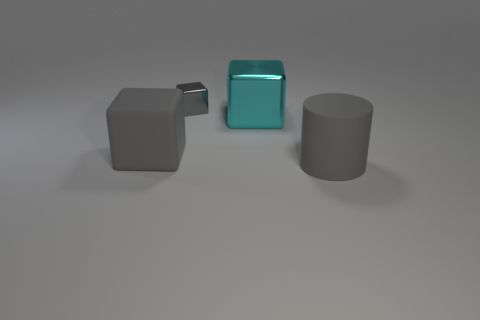Is the size of the gray metal block the same as the gray cylinder?
Provide a short and direct response. No. Are there any gray cubes behind the gray thing behind the large rubber thing that is to the left of the gray shiny block?
Keep it short and to the point. No. There is a big cyan thing that is the same shape as the small metallic object; what is its material?
Make the answer very short. Metal. What is the color of the rubber object to the right of the large cyan thing?
Give a very brief answer. Gray. The cyan shiny cube is what size?
Keep it short and to the point. Large. There is a gray rubber cylinder; is it the same size as the gray block left of the tiny gray block?
Make the answer very short. Yes. What color is the large rubber object that is on the left side of the large matte object to the right of the gray matte object left of the cylinder?
Your response must be concise. Gray. Are the thing behind the big shiny object and the cyan object made of the same material?
Your response must be concise. Yes. What number of other things are made of the same material as the gray cylinder?
Offer a terse response. 1. There is a cyan block that is the same size as the gray rubber cylinder; what is its material?
Provide a short and direct response. Metal. 